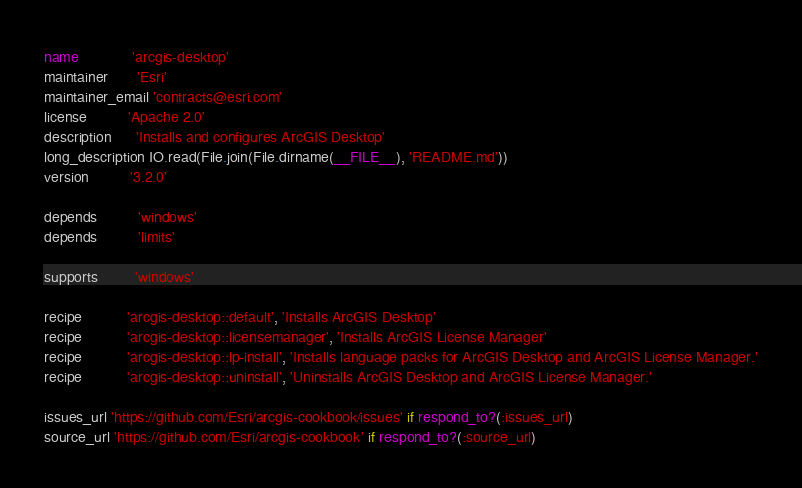Convert code to text. <code><loc_0><loc_0><loc_500><loc_500><_Ruby_>name             'arcgis-desktop'
maintainer       'Esri'
maintainer_email 'contracts@esri.com'
license          'Apache 2.0'
description      'Installs and configures ArcGIS Desktop'
long_description IO.read(File.join(File.dirname(__FILE__), 'README.md'))
version          '3.2.0'

depends          'windows'
depends          'limits'

supports         'windows'

recipe           'arcgis-desktop::default', 'Installs ArcGIS Desktop'
recipe           'arcgis-desktop::licensemanager', 'Installs ArcGIS License Manager'
recipe           'arcgis-desktop::lp-install', 'Installs language packs for ArcGIS Desktop and ArcGIS License Manager.'
recipe           'arcgis-desktop::uninstall', 'Uninstalls ArcGIS Desktop and ArcGIS License Manager.'

issues_url 'https://github.com/Esri/arcgis-cookbook/issues' if respond_to?(:issues_url)
source_url 'https://github.com/Esri/arcgis-cookbook' if respond_to?(:source_url)
</code> 